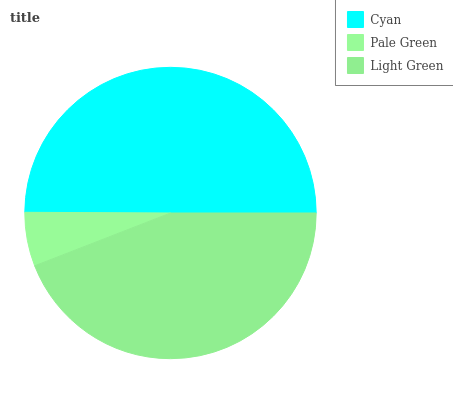Is Pale Green the minimum?
Answer yes or no. Yes. Is Cyan the maximum?
Answer yes or no. Yes. Is Light Green the minimum?
Answer yes or no. No. Is Light Green the maximum?
Answer yes or no. No. Is Light Green greater than Pale Green?
Answer yes or no. Yes. Is Pale Green less than Light Green?
Answer yes or no. Yes. Is Pale Green greater than Light Green?
Answer yes or no. No. Is Light Green less than Pale Green?
Answer yes or no. No. Is Light Green the high median?
Answer yes or no. Yes. Is Light Green the low median?
Answer yes or no. Yes. Is Cyan the high median?
Answer yes or no. No. Is Cyan the low median?
Answer yes or no. No. 